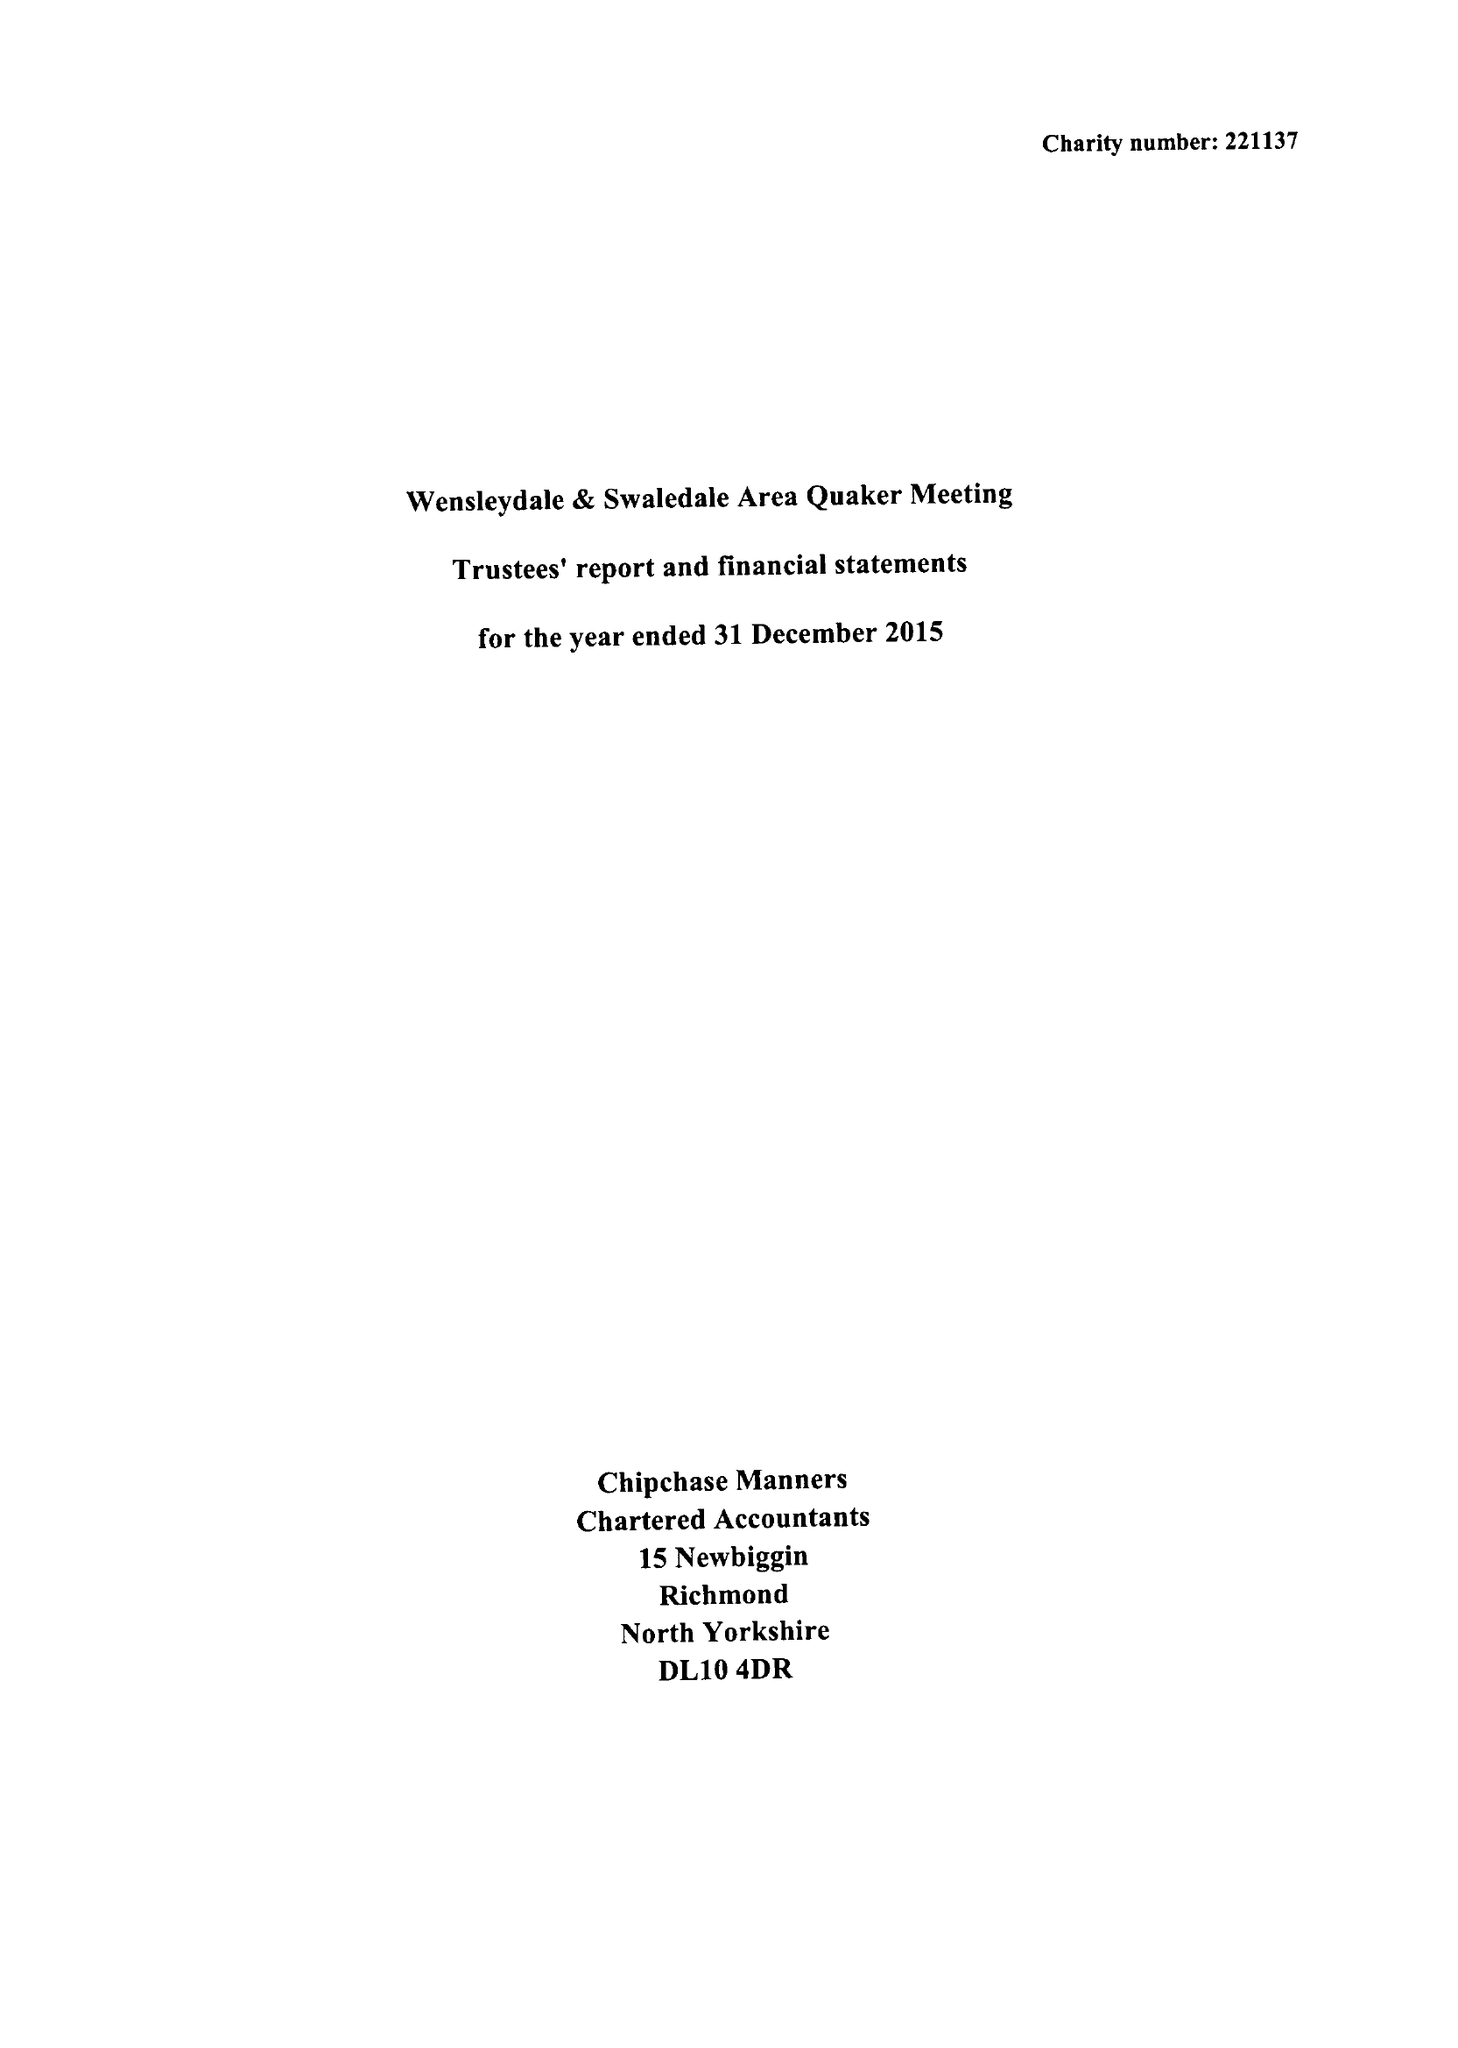What is the value for the address__post_town?
Answer the question using a single word or phrase. HAWES 